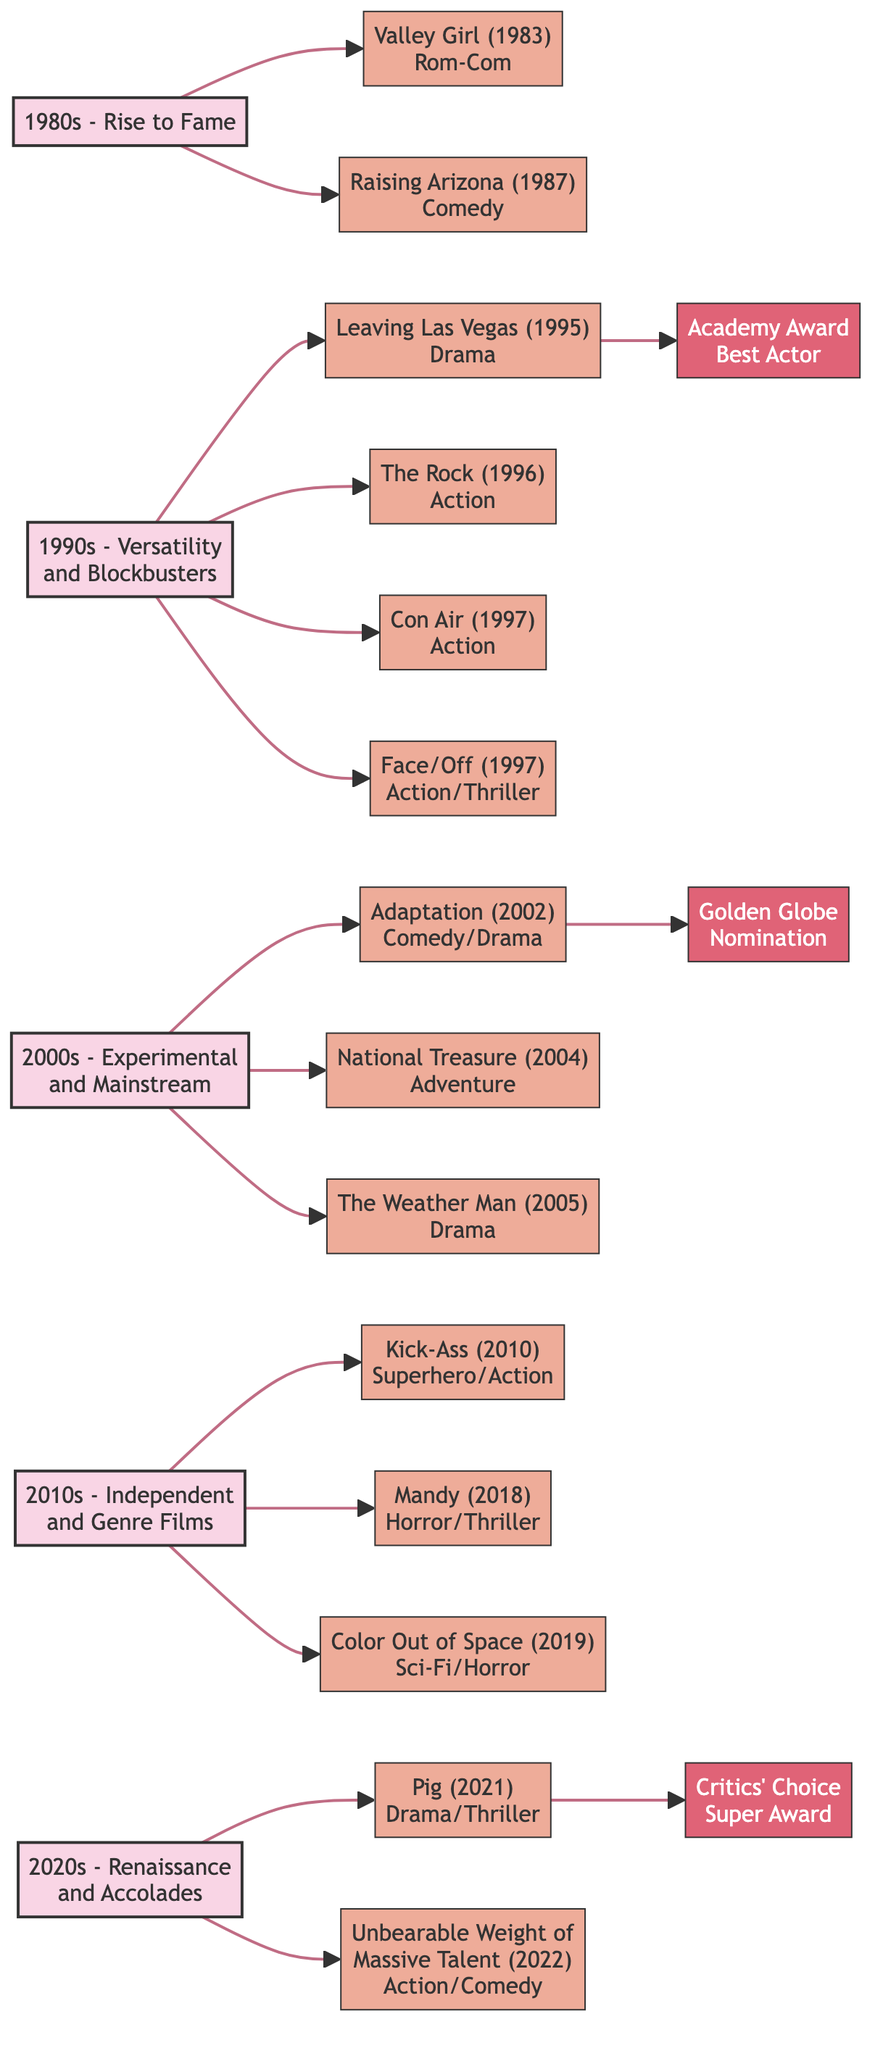What are the key films in the 1990s phase? The 1990s phase includes four key films: "Leaving Las Vegas (1995)", "The Rock (1996)", "Con Air (1997)", and "Face/Off (1997)".
Answer: Leaving Las Vegas, The Rock, Con Air, Face/Off How many awards are listed in the diagram? The diagram lists three awards: Academy Award for Best Actor, Golden Globe Nomination, and Critics' Choice Super Award for Best Actor.
Answer: 3 Which film in the 2000s received a Golden Globe Nomination? "Adaptation (2002)" in the 2000s phase received a Golden Globe Nomination.
Answer: Adaptation What genre is associated with "Mandy (2018)"? "Mandy (2018)" is associated with the Horror/Thriller genre.
Answer: Horror/Thriller What film marks the start of Nicolas Cage's career in the 1980s? "Valley Girl (1983)" marks the start of Nicolas Cage's career in the 1980s phase.
Answer: Valley Girl Which decade includes the film "Pig (2021)"? "Pig (2021)" is included in the 2020s phase.
Answer: 2020s Name one film from the 1980s phase that is a romantic comedy. "Valley Girl (1983)" is the film from the 1980s phase that is a romantic comedy.
Answer: Valley Girl How many films fall under the action genre in the 1990s? There are three films that fall under the action genre in the 1990s: "The Rock", "Con Air", and "Face/Off".
Answer: 3 In which phase is the film "National Treasure (2004)" located? "National Treasure (2004)" is located in the 2000s phase.
Answer: 2000s 